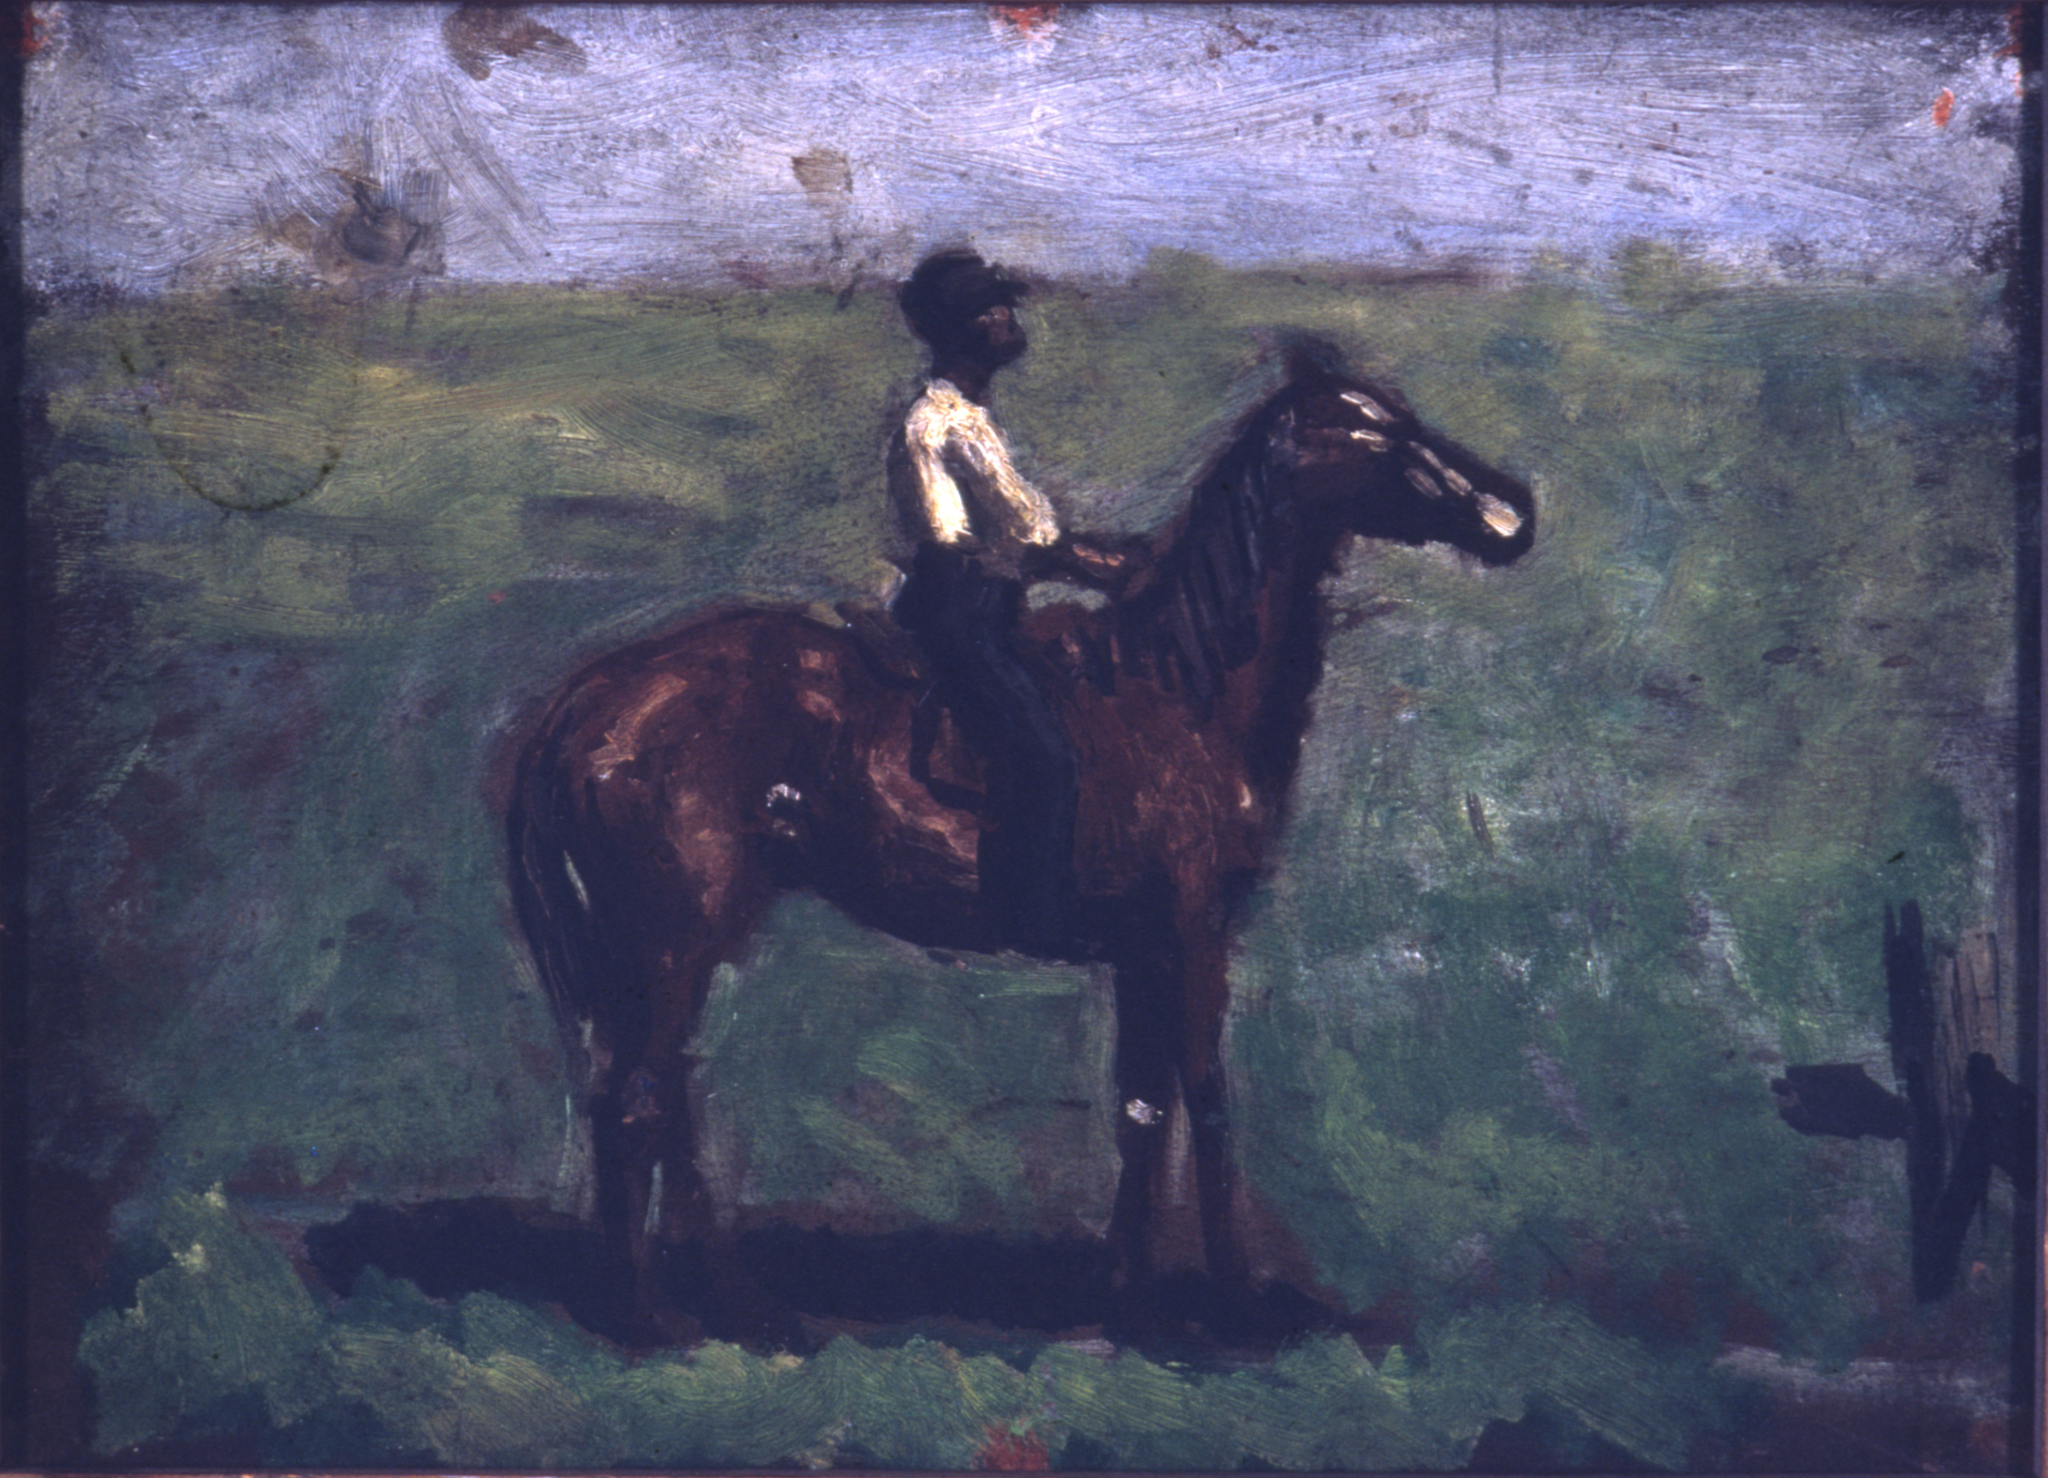Could you tell a story about the man on the horse? Years ago, in a small village on the outskirts of France, there lived a man named Henri. Every evening, Henri would ride his beloved horse, Noire, through the sprawling meadows that surrounded his village. It was the only time he truly felt at peace, away from the demands of his daily life as a farmer. On these rides, Henri would dream of faraway lands and new adventures, even if he knew deep down he was destined to stay in his village. The landscape, with its whispering trees and endless skies, became a canvas for his dreams, allowing him a brief respite from the ordinary to envision the extraordinary. What does Henri feel while riding through these meadows? Henri feels an overwhelming sense of freedom and contentment as he rides through the meadows. The tranquility of the landscape and the rhythmic motion of his horse help him connect with nature on a profound level. Each ride brings him a different perspective of the world around him, enriching his soul and fulfilling his yearning for peace and simplicity. Imagine a very bizarre scenario involving the man and the horse. In a twist of fate, as Henri rides through an unfamiliar part of the meadow, he stumbles upon a portal hidden among the tall grasses. As he and Noire pass through the glowing entrance, they are transported to a fantastical world where horses have wings and humans can communicate telepathically with animals. In this strange new land, Henri and Noire embark on a series of adventures, making friends with mythical creatures and discovering ancient secrets that alter his perception of reality forever. 